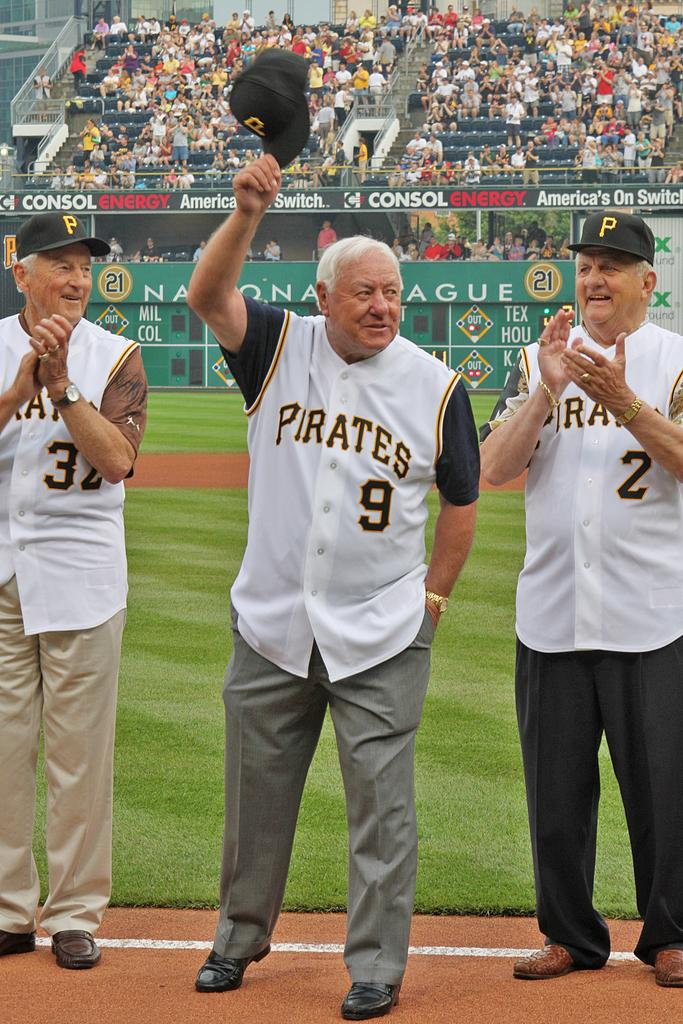<image>
Describe the image concisely. The coaches for the pirates baseball team waving their hat to the crowd 